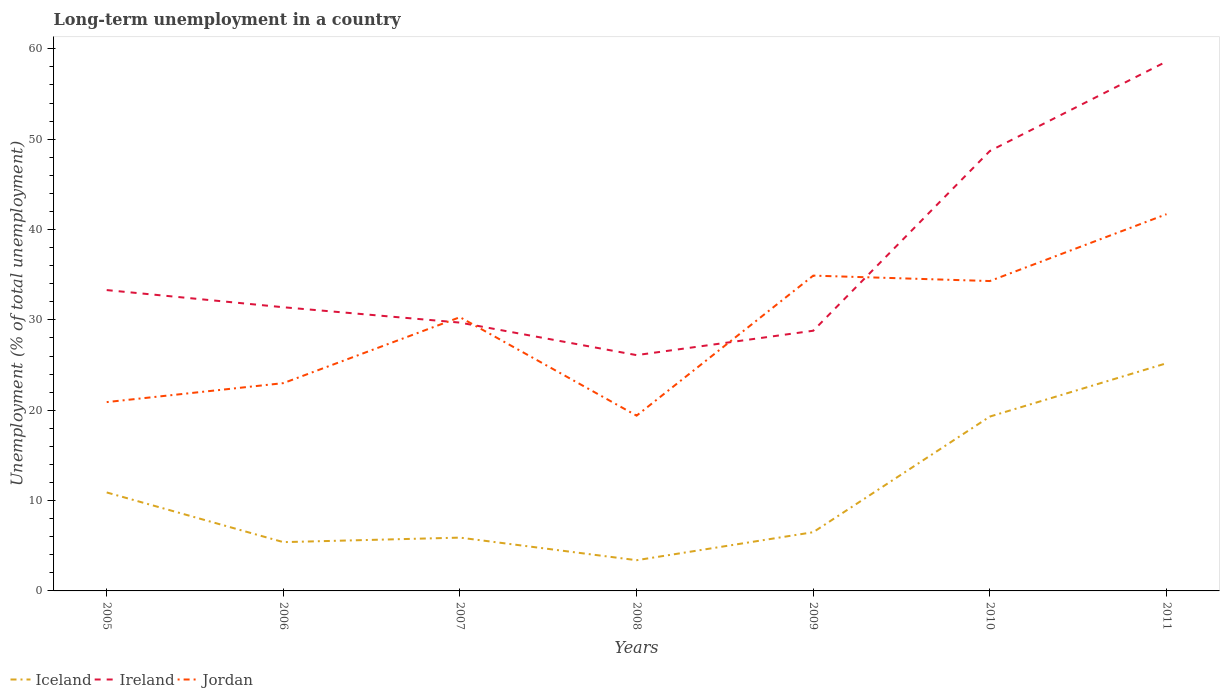Does the line corresponding to Ireland intersect with the line corresponding to Iceland?
Give a very brief answer. No. Across all years, what is the maximum percentage of long-term unemployed population in Jordan?
Provide a succinct answer. 19.4. What is the total percentage of long-term unemployed population in Jordan in the graph?
Provide a succinct answer. -7.3. What is the difference between the highest and the second highest percentage of long-term unemployed population in Iceland?
Make the answer very short. 21.8. What is the difference between the highest and the lowest percentage of long-term unemployed population in Ireland?
Ensure brevity in your answer.  2. Is the percentage of long-term unemployed population in Iceland strictly greater than the percentage of long-term unemployed population in Ireland over the years?
Your answer should be very brief. Yes. What is the difference between two consecutive major ticks on the Y-axis?
Your answer should be compact. 10. Does the graph contain any zero values?
Provide a short and direct response. No. Does the graph contain grids?
Your answer should be compact. No. Where does the legend appear in the graph?
Provide a short and direct response. Bottom left. How are the legend labels stacked?
Your response must be concise. Horizontal. What is the title of the graph?
Offer a very short reply. Long-term unemployment in a country. Does "North America" appear as one of the legend labels in the graph?
Provide a succinct answer. No. What is the label or title of the X-axis?
Offer a terse response. Years. What is the label or title of the Y-axis?
Keep it short and to the point. Unemployment (% of total unemployment). What is the Unemployment (% of total unemployment) in Iceland in 2005?
Make the answer very short. 10.9. What is the Unemployment (% of total unemployment) of Ireland in 2005?
Offer a very short reply. 33.3. What is the Unemployment (% of total unemployment) in Jordan in 2005?
Offer a very short reply. 20.9. What is the Unemployment (% of total unemployment) in Iceland in 2006?
Make the answer very short. 5.4. What is the Unemployment (% of total unemployment) of Ireland in 2006?
Give a very brief answer. 31.4. What is the Unemployment (% of total unemployment) of Iceland in 2007?
Give a very brief answer. 5.9. What is the Unemployment (% of total unemployment) of Ireland in 2007?
Provide a short and direct response. 29.7. What is the Unemployment (% of total unemployment) of Jordan in 2007?
Offer a very short reply. 30.3. What is the Unemployment (% of total unemployment) in Iceland in 2008?
Provide a short and direct response. 3.4. What is the Unemployment (% of total unemployment) of Ireland in 2008?
Keep it short and to the point. 26.1. What is the Unemployment (% of total unemployment) in Jordan in 2008?
Your answer should be very brief. 19.4. What is the Unemployment (% of total unemployment) in Iceland in 2009?
Your answer should be compact. 6.5. What is the Unemployment (% of total unemployment) of Ireland in 2009?
Your answer should be compact. 28.8. What is the Unemployment (% of total unemployment) in Jordan in 2009?
Provide a short and direct response. 34.9. What is the Unemployment (% of total unemployment) in Iceland in 2010?
Give a very brief answer. 19.3. What is the Unemployment (% of total unemployment) of Ireland in 2010?
Make the answer very short. 48.7. What is the Unemployment (% of total unemployment) of Jordan in 2010?
Provide a short and direct response. 34.3. What is the Unemployment (% of total unemployment) of Iceland in 2011?
Provide a short and direct response. 25.2. What is the Unemployment (% of total unemployment) of Ireland in 2011?
Provide a short and direct response. 58.6. What is the Unemployment (% of total unemployment) in Jordan in 2011?
Provide a short and direct response. 41.7. Across all years, what is the maximum Unemployment (% of total unemployment) of Iceland?
Make the answer very short. 25.2. Across all years, what is the maximum Unemployment (% of total unemployment) of Ireland?
Offer a very short reply. 58.6. Across all years, what is the maximum Unemployment (% of total unemployment) of Jordan?
Offer a terse response. 41.7. Across all years, what is the minimum Unemployment (% of total unemployment) in Iceland?
Ensure brevity in your answer.  3.4. Across all years, what is the minimum Unemployment (% of total unemployment) in Ireland?
Provide a short and direct response. 26.1. Across all years, what is the minimum Unemployment (% of total unemployment) in Jordan?
Give a very brief answer. 19.4. What is the total Unemployment (% of total unemployment) in Iceland in the graph?
Make the answer very short. 76.6. What is the total Unemployment (% of total unemployment) of Ireland in the graph?
Give a very brief answer. 256.6. What is the total Unemployment (% of total unemployment) in Jordan in the graph?
Provide a short and direct response. 204.5. What is the difference between the Unemployment (% of total unemployment) of Iceland in 2005 and that in 2006?
Provide a succinct answer. 5.5. What is the difference between the Unemployment (% of total unemployment) in Ireland in 2005 and that in 2006?
Give a very brief answer. 1.9. What is the difference between the Unemployment (% of total unemployment) in Iceland in 2005 and that in 2008?
Give a very brief answer. 7.5. What is the difference between the Unemployment (% of total unemployment) of Ireland in 2005 and that in 2009?
Keep it short and to the point. 4.5. What is the difference between the Unemployment (% of total unemployment) of Jordan in 2005 and that in 2009?
Provide a short and direct response. -14. What is the difference between the Unemployment (% of total unemployment) of Ireland in 2005 and that in 2010?
Offer a terse response. -15.4. What is the difference between the Unemployment (% of total unemployment) of Iceland in 2005 and that in 2011?
Give a very brief answer. -14.3. What is the difference between the Unemployment (% of total unemployment) in Ireland in 2005 and that in 2011?
Offer a very short reply. -25.3. What is the difference between the Unemployment (% of total unemployment) in Jordan in 2005 and that in 2011?
Your answer should be compact. -20.8. What is the difference between the Unemployment (% of total unemployment) in Ireland in 2006 and that in 2007?
Your response must be concise. 1.7. What is the difference between the Unemployment (% of total unemployment) of Ireland in 2006 and that in 2008?
Ensure brevity in your answer.  5.3. What is the difference between the Unemployment (% of total unemployment) of Jordan in 2006 and that in 2008?
Your answer should be very brief. 3.6. What is the difference between the Unemployment (% of total unemployment) of Ireland in 2006 and that in 2009?
Keep it short and to the point. 2.6. What is the difference between the Unemployment (% of total unemployment) in Jordan in 2006 and that in 2009?
Provide a short and direct response. -11.9. What is the difference between the Unemployment (% of total unemployment) of Ireland in 2006 and that in 2010?
Your answer should be very brief. -17.3. What is the difference between the Unemployment (% of total unemployment) in Jordan in 2006 and that in 2010?
Provide a succinct answer. -11.3. What is the difference between the Unemployment (% of total unemployment) of Iceland in 2006 and that in 2011?
Give a very brief answer. -19.8. What is the difference between the Unemployment (% of total unemployment) in Ireland in 2006 and that in 2011?
Give a very brief answer. -27.2. What is the difference between the Unemployment (% of total unemployment) of Jordan in 2006 and that in 2011?
Offer a terse response. -18.7. What is the difference between the Unemployment (% of total unemployment) in Iceland in 2007 and that in 2008?
Provide a short and direct response. 2.5. What is the difference between the Unemployment (% of total unemployment) in Iceland in 2007 and that in 2009?
Make the answer very short. -0.6. What is the difference between the Unemployment (% of total unemployment) of Ireland in 2007 and that in 2009?
Make the answer very short. 0.9. What is the difference between the Unemployment (% of total unemployment) of Ireland in 2007 and that in 2010?
Provide a short and direct response. -19. What is the difference between the Unemployment (% of total unemployment) of Jordan in 2007 and that in 2010?
Make the answer very short. -4. What is the difference between the Unemployment (% of total unemployment) in Iceland in 2007 and that in 2011?
Your answer should be compact. -19.3. What is the difference between the Unemployment (% of total unemployment) in Ireland in 2007 and that in 2011?
Your response must be concise. -28.9. What is the difference between the Unemployment (% of total unemployment) of Iceland in 2008 and that in 2009?
Keep it short and to the point. -3.1. What is the difference between the Unemployment (% of total unemployment) of Jordan in 2008 and that in 2009?
Give a very brief answer. -15.5. What is the difference between the Unemployment (% of total unemployment) of Iceland in 2008 and that in 2010?
Offer a very short reply. -15.9. What is the difference between the Unemployment (% of total unemployment) of Ireland in 2008 and that in 2010?
Keep it short and to the point. -22.6. What is the difference between the Unemployment (% of total unemployment) of Jordan in 2008 and that in 2010?
Keep it short and to the point. -14.9. What is the difference between the Unemployment (% of total unemployment) in Iceland in 2008 and that in 2011?
Your answer should be compact. -21.8. What is the difference between the Unemployment (% of total unemployment) of Ireland in 2008 and that in 2011?
Provide a short and direct response. -32.5. What is the difference between the Unemployment (% of total unemployment) in Jordan in 2008 and that in 2011?
Your answer should be compact. -22.3. What is the difference between the Unemployment (% of total unemployment) of Iceland in 2009 and that in 2010?
Give a very brief answer. -12.8. What is the difference between the Unemployment (% of total unemployment) of Ireland in 2009 and that in 2010?
Ensure brevity in your answer.  -19.9. What is the difference between the Unemployment (% of total unemployment) of Jordan in 2009 and that in 2010?
Provide a succinct answer. 0.6. What is the difference between the Unemployment (% of total unemployment) of Iceland in 2009 and that in 2011?
Ensure brevity in your answer.  -18.7. What is the difference between the Unemployment (% of total unemployment) in Ireland in 2009 and that in 2011?
Ensure brevity in your answer.  -29.8. What is the difference between the Unemployment (% of total unemployment) in Iceland in 2010 and that in 2011?
Your response must be concise. -5.9. What is the difference between the Unemployment (% of total unemployment) of Ireland in 2010 and that in 2011?
Provide a succinct answer. -9.9. What is the difference between the Unemployment (% of total unemployment) in Jordan in 2010 and that in 2011?
Offer a terse response. -7.4. What is the difference between the Unemployment (% of total unemployment) of Iceland in 2005 and the Unemployment (% of total unemployment) of Ireland in 2006?
Provide a short and direct response. -20.5. What is the difference between the Unemployment (% of total unemployment) of Iceland in 2005 and the Unemployment (% of total unemployment) of Jordan in 2006?
Keep it short and to the point. -12.1. What is the difference between the Unemployment (% of total unemployment) in Ireland in 2005 and the Unemployment (% of total unemployment) in Jordan in 2006?
Provide a succinct answer. 10.3. What is the difference between the Unemployment (% of total unemployment) in Iceland in 2005 and the Unemployment (% of total unemployment) in Ireland in 2007?
Make the answer very short. -18.8. What is the difference between the Unemployment (% of total unemployment) in Iceland in 2005 and the Unemployment (% of total unemployment) in Jordan in 2007?
Make the answer very short. -19.4. What is the difference between the Unemployment (% of total unemployment) of Ireland in 2005 and the Unemployment (% of total unemployment) of Jordan in 2007?
Your answer should be compact. 3. What is the difference between the Unemployment (% of total unemployment) of Iceland in 2005 and the Unemployment (% of total unemployment) of Ireland in 2008?
Your answer should be compact. -15.2. What is the difference between the Unemployment (% of total unemployment) in Iceland in 2005 and the Unemployment (% of total unemployment) in Jordan in 2008?
Provide a succinct answer. -8.5. What is the difference between the Unemployment (% of total unemployment) in Ireland in 2005 and the Unemployment (% of total unemployment) in Jordan in 2008?
Ensure brevity in your answer.  13.9. What is the difference between the Unemployment (% of total unemployment) of Iceland in 2005 and the Unemployment (% of total unemployment) of Ireland in 2009?
Provide a succinct answer. -17.9. What is the difference between the Unemployment (% of total unemployment) of Ireland in 2005 and the Unemployment (% of total unemployment) of Jordan in 2009?
Your answer should be very brief. -1.6. What is the difference between the Unemployment (% of total unemployment) in Iceland in 2005 and the Unemployment (% of total unemployment) in Ireland in 2010?
Provide a succinct answer. -37.8. What is the difference between the Unemployment (% of total unemployment) in Iceland in 2005 and the Unemployment (% of total unemployment) in Jordan in 2010?
Provide a succinct answer. -23.4. What is the difference between the Unemployment (% of total unemployment) of Iceland in 2005 and the Unemployment (% of total unemployment) of Ireland in 2011?
Make the answer very short. -47.7. What is the difference between the Unemployment (% of total unemployment) of Iceland in 2005 and the Unemployment (% of total unemployment) of Jordan in 2011?
Keep it short and to the point. -30.8. What is the difference between the Unemployment (% of total unemployment) of Iceland in 2006 and the Unemployment (% of total unemployment) of Ireland in 2007?
Provide a succinct answer. -24.3. What is the difference between the Unemployment (% of total unemployment) of Iceland in 2006 and the Unemployment (% of total unemployment) of Jordan in 2007?
Your response must be concise. -24.9. What is the difference between the Unemployment (% of total unemployment) in Iceland in 2006 and the Unemployment (% of total unemployment) in Ireland in 2008?
Make the answer very short. -20.7. What is the difference between the Unemployment (% of total unemployment) of Iceland in 2006 and the Unemployment (% of total unemployment) of Jordan in 2008?
Make the answer very short. -14. What is the difference between the Unemployment (% of total unemployment) in Ireland in 2006 and the Unemployment (% of total unemployment) in Jordan in 2008?
Your answer should be very brief. 12. What is the difference between the Unemployment (% of total unemployment) in Iceland in 2006 and the Unemployment (% of total unemployment) in Ireland in 2009?
Offer a very short reply. -23.4. What is the difference between the Unemployment (% of total unemployment) of Iceland in 2006 and the Unemployment (% of total unemployment) of Jordan in 2009?
Give a very brief answer. -29.5. What is the difference between the Unemployment (% of total unemployment) in Ireland in 2006 and the Unemployment (% of total unemployment) in Jordan in 2009?
Offer a terse response. -3.5. What is the difference between the Unemployment (% of total unemployment) in Iceland in 2006 and the Unemployment (% of total unemployment) in Ireland in 2010?
Provide a short and direct response. -43.3. What is the difference between the Unemployment (% of total unemployment) of Iceland in 2006 and the Unemployment (% of total unemployment) of Jordan in 2010?
Keep it short and to the point. -28.9. What is the difference between the Unemployment (% of total unemployment) of Iceland in 2006 and the Unemployment (% of total unemployment) of Ireland in 2011?
Your answer should be very brief. -53.2. What is the difference between the Unemployment (% of total unemployment) of Iceland in 2006 and the Unemployment (% of total unemployment) of Jordan in 2011?
Offer a very short reply. -36.3. What is the difference between the Unemployment (% of total unemployment) of Iceland in 2007 and the Unemployment (% of total unemployment) of Ireland in 2008?
Your answer should be compact. -20.2. What is the difference between the Unemployment (% of total unemployment) in Ireland in 2007 and the Unemployment (% of total unemployment) in Jordan in 2008?
Make the answer very short. 10.3. What is the difference between the Unemployment (% of total unemployment) of Iceland in 2007 and the Unemployment (% of total unemployment) of Ireland in 2009?
Provide a short and direct response. -22.9. What is the difference between the Unemployment (% of total unemployment) in Iceland in 2007 and the Unemployment (% of total unemployment) in Ireland in 2010?
Make the answer very short. -42.8. What is the difference between the Unemployment (% of total unemployment) of Iceland in 2007 and the Unemployment (% of total unemployment) of Jordan in 2010?
Give a very brief answer. -28.4. What is the difference between the Unemployment (% of total unemployment) of Iceland in 2007 and the Unemployment (% of total unemployment) of Ireland in 2011?
Keep it short and to the point. -52.7. What is the difference between the Unemployment (% of total unemployment) in Iceland in 2007 and the Unemployment (% of total unemployment) in Jordan in 2011?
Make the answer very short. -35.8. What is the difference between the Unemployment (% of total unemployment) of Ireland in 2007 and the Unemployment (% of total unemployment) of Jordan in 2011?
Provide a short and direct response. -12. What is the difference between the Unemployment (% of total unemployment) of Iceland in 2008 and the Unemployment (% of total unemployment) of Ireland in 2009?
Offer a very short reply. -25.4. What is the difference between the Unemployment (% of total unemployment) of Iceland in 2008 and the Unemployment (% of total unemployment) of Jordan in 2009?
Ensure brevity in your answer.  -31.5. What is the difference between the Unemployment (% of total unemployment) of Ireland in 2008 and the Unemployment (% of total unemployment) of Jordan in 2009?
Your answer should be compact. -8.8. What is the difference between the Unemployment (% of total unemployment) of Iceland in 2008 and the Unemployment (% of total unemployment) of Ireland in 2010?
Keep it short and to the point. -45.3. What is the difference between the Unemployment (% of total unemployment) in Iceland in 2008 and the Unemployment (% of total unemployment) in Jordan in 2010?
Provide a succinct answer. -30.9. What is the difference between the Unemployment (% of total unemployment) in Ireland in 2008 and the Unemployment (% of total unemployment) in Jordan in 2010?
Your answer should be compact. -8.2. What is the difference between the Unemployment (% of total unemployment) in Iceland in 2008 and the Unemployment (% of total unemployment) in Ireland in 2011?
Your response must be concise. -55.2. What is the difference between the Unemployment (% of total unemployment) of Iceland in 2008 and the Unemployment (% of total unemployment) of Jordan in 2011?
Provide a succinct answer. -38.3. What is the difference between the Unemployment (% of total unemployment) in Ireland in 2008 and the Unemployment (% of total unemployment) in Jordan in 2011?
Offer a terse response. -15.6. What is the difference between the Unemployment (% of total unemployment) of Iceland in 2009 and the Unemployment (% of total unemployment) of Ireland in 2010?
Your answer should be compact. -42.2. What is the difference between the Unemployment (% of total unemployment) of Iceland in 2009 and the Unemployment (% of total unemployment) of Jordan in 2010?
Give a very brief answer. -27.8. What is the difference between the Unemployment (% of total unemployment) of Iceland in 2009 and the Unemployment (% of total unemployment) of Ireland in 2011?
Your answer should be very brief. -52.1. What is the difference between the Unemployment (% of total unemployment) of Iceland in 2009 and the Unemployment (% of total unemployment) of Jordan in 2011?
Ensure brevity in your answer.  -35.2. What is the difference between the Unemployment (% of total unemployment) in Ireland in 2009 and the Unemployment (% of total unemployment) in Jordan in 2011?
Keep it short and to the point. -12.9. What is the difference between the Unemployment (% of total unemployment) in Iceland in 2010 and the Unemployment (% of total unemployment) in Ireland in 2011?
Your answer should be very brief. -39.3. What is the difference between the Unemployment (% of total unemployment) in Iceland in 2010 and the Unemployment (% of total unemployment) in Jordan in 2011?
Your response must be concise. -22.4. What is the average Unemployment (% of total unemployment) in Iceland per year?
Keep it short and to the point. 10.94. What is the average Unemployment (% of total unemployment) in Ireland per year?
Give a very brief answer. 36.66. What is the average Unemployment (% of total unemployment) in Jordan per year?
Ensure brevity in your answer.  29.21. In the year 2005, what is the difference between the Unemployment (% of total unemployment) in Iceland and Unemployment (% of total unemployment) in Ireland?
Your response must be concise. -22.4. In the year 2005, what is the difference between the Unemployment (% of total unemployment) in Ireland and Unemployment (% of total unemployment) in Jordan?
Offer a terse response. 12.4. In the year 2006, what is the difference between the Unemployment (% of total unemployment) of Iceland and Unemployment (% of total unemployment) of Ireland?
Ensure brevity in your answer.  -26. In the year 2006, what is the difference between the Unemployment (% of total unemployment) of Iceland and Unemployment (% of total unemployment) of Jordan?
Provide a short and direct response. -17.6. In the year 2007, what is the difference between the Unemployment (% of total unemployment) of Iceland and Unemployment (% of total unemployment) of Ireland?
Make the answer very short. -23.8. In the year 2007, what is the difference between the Unemployment (% of total unemployment) in Iceland and Unemployment (% of total unemployment) in Jordan?
Ensure brevity in your answer.  -24.4. In the year 2007, what is the difference between the Unemployment (% of total unemployment) in Ireland and Unemployment (% of total unemployment) in Jordan?
Offer a terse response. -0.6. In the year 2008, what is the difference between the Unemployment (% of total unemployment) of Iceland and Unemployment (% of total unemployment) of Ireland?
Ensure brevity in your answer.  -22.7. In the year 2009, what is the difference between the Unemployment (% of total unemployment) of Iceland and Unemployment (% of total unemployment) of Ireland?
Your answer should be very brief. -22.3. In the year 2009, what is the difference between the Unemployment (% of total unemployment) in Iceland and Unemployment (% of total unemployment) in Jordan?
Your answer should be compact. -28.4. In the year 2010, what is the difference between the Unemployment (% of total unemployment) of Iceland and Unemployment (% of total unemployment) of Ireland?
Make the answer very short. -29.4. In the year 2010, what is the difference between the Unemployment (% of total unemployment) of Iceland and Unemployment (% of total unemployment) of Jordan?
Give a very brief answer. -15. In the year 2010, what is the difference between the Unemployment (% of total unemployment) in Ireland and Unemployment (% of total unemployment) in Jordan?
Offer a terse response. 14.4. In the year 2011, what is the difference between the Unemployment (% of total unemployment) in Iceland and Unemployment (% of total unemployment) in Ireland?
Provide a succinct answer. -33.4. In the year 2011, what is the difference between the Unemployment (% of total unemployment) in Iceland and Unemployment (% of total unemployment) in Jordan?
Your response must be concise. -16.5. In the year 2011, what is the difference between the Unemployment (% of total unemployment) in Ireland and Unemployment (% of total unemployment) in Jordan?
Give a very brief answer. 16.9. What is the ratio of the Unemployment (% of total unemployment) in Iceland in 2005 to that in 2006?
Your answer should be very brief. 2.02. What is the ratio of the Unemployment (% of total unemployment) in Ireland in 2005 to that in 2006?
Provide a succinct answer. 1.06. What is the ratio of the Unemployment (% of total unemployment) of Jordan in 2005 to that in 2006?
Your response must be concise. 0.91. What is the ratio of the Unemployment (% of total unemployment) of Iceland in 2005 to that in 2007?
Your answer should be very brief. 1.85. What is the ratio of the Unemployment (% of total unemployment) in Ireland in 2005 to that in 2007?
Offer a terse response. 1.12. What is the ratio of the Unemployment (% of total unemployment) in Jordan in 2005 to that in 2007?
Provide a succinct answer. 0.69. What is the ratio of the Unemployment (% of total unemployment) in Iceland in 2005 to that in 2008?
Make the answer very short. 3.21. What is the ratio of the Unemployment (% of total unemployment) of Ireland in 2005 to that in 2008?
Provide a succinct answer. 1.28. What is the ratio of the Unemployment (% of total unemployment) in Jordan in 2005 to that in 2008?
Offer a terse response. 1.08. What is the ratio of the Unemployment (% of total unemployment) of Iceland in 2005 to that in 2009?
Your answer should be very brief. 1.68. What is the ratio of the Unemployment (% of total unemployment) in Ireland in 2005 to that in 2009?
Your answer should be very brief. 1.16. What is the ratio of the Unemployment (% of total unemployment) of Jordan in 2005 to that in 2009?
Ensure brevity in your answer.  0.6. What is the ratio of the Unemployment (% of total unemployment) of Iceland in 2005 to that in 2010?
Your response must be concise. 0.56. What is the ratio of the Unemployment (% of total unemployment) of Ireland in 2005 to that in 2010?
Your answer should be compact. 0.68. What is the ratio of the Unemployment (% of total unemployment) in Jordan in 2005 to that in 2010?
Your response must be concise. 0.61. What is the ratio of the Unemployment (% of total unemployment) of Iceland in 2005 to that in 2011?
Your answer should be very brief. 0.43. What is the ratio of the Unemployment (% of total unemployment) in Ireland in 2005 to that in 2011?
Offer a terse response. 0.57. What is the ratio of the Unemployment (% of total unemployment) of Jordan in 2005 to that in 2011?
Ensure brevity in your answer.  0.5. What is the ratio of the Unemployment (% of total unemployment) of Iceland in 2006 to that in 2007?
Your answer should be very brief. 0.92. What is the ratio of the Unemployment (% of total unemployment) of Ireland in 2006 to that in 2007?
Provide a short and direct response. 1.06. What is the ratio of the Unemployment (% of total unemployment) in Jordan in 2006 to that in 2007?
Offer a very short reply. 0.76. What is the ratio of the Unemployment (% of total unemployment) of Iceland in 2006 to that in 2008?
Give a very brief answer. 1.59. What is the ratio of the Unemployment (% of total unemployment) of Ireland in 2006 to that in 2008?
Give a very brief answer. 1.2. What is the ratio of the Unemployment (% of total unemployment) in Jordan in 2006 to that in 2008?
Provide a succinct answer. 1.19. What is the ratio of the Unemployment (% of total unemployment) of Iceland in 2006 to that in 2009?
Your answer should be compact. 0.83. What is the ratio of the Unemployment (% of total unemployment) of Ireland in 2006 to that in 2009?
Provide a short and direct response. 1.09. What is the ratio of the Unemployment (% of total unemployment) of Jordan in 2006 to that in 2009?
Your response must be concise. 0.66. What is the ratio of the Unemployment (% of total unemployment) of Iceland in 2006 to that in 2010?
Make the answer very short. 0.28. What is the ratio of the Unemployment (% of total unemployment) in Ireland in 2006 to that in 2010?
Ensure brevity in your answer.  0.64. What is the ratio of the Unemployment (% of total unemployment) in Jordan in 2006 to that in 2010?
Provide a succinct answer. 0.67. What is the ratio of the Unemployment (% of total unemployment) of Iceland in 2006 to that in 2011?
Offer a very short reply. 0.21. What is the ratio of the Unemployment (% of total unemployment) of Ireland in 2006 to that in 2011?
Provide a succinct answer. 0.54. What is the ratio of the Unemployment (% of total unemployment) of Jordan in 2006 to that in 2011?
Offer a very short reply. 0.55. What is the ratio of the Unemployment (% of total unemployment) in Iceland in 2007 to that in 2008?
Ensure brevity in your answer.  1.74. What is the ratio of the Unemployment (% of total unemployment) in Ireland in 2007 to that in 2008?
Your answer should be very brief. 1.14. What is the ratio of the Unemployment (% of total unemployment) of Jordan in 2007 to that in 2008?
Your answer should be very brief. 1.56. What is the ratio of the Unemployment (% of total unemployment) in Iceland in 2007 to that in 2009?
Offer a very short reply. 0.91. What is the ratio of the Unemployment (% of total unemployment) of Ireland in 2007 to that in 2009?
Give a very brief answer. 1.03. What is the ratio of the Unemployment (% of total unemployment) in Jordan in 2007 to that in 2009?
Provide a succinct answer. 0.87. What is the ratio of the Unemployment (% of total unemployment) of Iceland in 2007 to that in 2010?
Ensure brevity in your answer.  0.31. What is the ratio of the Unemployment (% of total unemployment) in Ireland in 2007 to that in 2010?
Offer a very short reply. 0.61. What is the ratio of the Unemployment (% of total unemployment) of Jordan in 2007 to that in 2010?
Keep it short and to the point. 0.88. What is the ratio of the Unemployment (% of total unemployment) of Iceland in 2007 to that in 2011?
Ensure brevity in your answer.  0.23. What is the ratio of the Unemployment (% of total unemployment) in Ireland in 2007 to that in 2011?
Ensure brevity in your answer.  0.51. What is the ratio of the Unemployment (% of total unemployment) of Jordan in 2007 to that in 2011?
Give a very brief answer. 0.73. What is the ratio of the Unemployment (% of total unemployment) in Iceland in 2008 to that in 2009?
Provide a short and direct response. 0.52. What is the ratio of the Unemployment (% of total unemployment) in Ireland in 2008 to that in 2009?
Your response must be concise. 0.91. What is the ratio of the Unemployment (% of total unemployment) in Jordan in 2008 to that in 2009?
Your answer should be very brief. 0.56. What is the ratio of the Unemployment (% of total unemployment) in Iceland in 2008 to that in 2010?
Provide a succinct answer. 0.18. What is the ratio of the Unemployment (% of total unemployment) in Ireland in 2008 to that in 2010?
Give a very brief answer. 0.54. What is the ratio of the Unemployment (% of total unemployment) in Jordan in 2008 to that in 2010?
Keep it short and to the point. 0.57. What is the ratio of the Unemployment (% of total unemployment) in Iceland in 2008 to that in 2011?
Keep it short and to the point. 0.13. What is the ratio of the Unemployment (% of total unemployment) in Ireland in 2008 to that in 2011?
Keep it short and to the point. 0.45. What is the ratio of the Unemployment (% of total unemployment) of Jordan in 2008 to that in 2011?
Offer a terse response. 0.47. What is the ratio of the Unemployment (% of total unemployment) in Iceland in 2009 to that in 2010?
Ensure brevity in your answer.  0.34. What is the ratio of the Unemployment (% of total unemployment) in Ireland in 2009 to that in 2010?
Offer a very short reply. 0.59. What is the ratio of the Unemployment (% of total unemployment) of Jordan in 2009 to that in 2010?
Ensure brevity in your answer.  1.02. What is the ratio of the Unemployment (% of total unemployment) of Iceland in 2009 to that in 2011?
Provide a short and direct response. 0.26. What is the ratio of the Unemployment (% of total unemployment) of Ireland in 2009 to that in 2011?
Ensure brevity in your answer.  0.49. What is the ratio of the Unemployment (% of total unemployment) of Jordan in 2009 to that in 2011?
Provide a succinct answer. 0.84. What is the ratio of the Unemployment (% of total unemployment) in Iceland in 2010 to that in 2011?
Give a very brief answer. 0.77. What is the ratio of the Unemployment (% of total unemployment) in Ireland in 2010 to that in 2011?
Provide a short and direct response. 0.83. What is the ratio of the Unemployment (% of total unemployment) of Jordan in 2010 to that in 2011?
Your response must be concise. 0.82. What is the difference between the highest and the second highest Unemployment (% of total unemployment) in Iceland?
Your answer should be compact. 5.9. What is the difference between the highest and the second highest Unemployment (% of total unemployment) of Ireland?
Provide a short and direct response. 9.9. What is the difference between the highest and the second highest Unemployment (% of total unemployment) of Jordan?
Your answer should be very brief. 6.8. What is the difference between the highest and the lowest Unemployment (% of total unemployment) of Iceland?
Your response must be concise. 21.8. What is the difference between the highest and the lowest Unemployment (% of total unemployment) of Ireland?
Ensure brevity in your answer.  32.5. What is the difference between the highest and the lowest Unemployment (% of total unemployment) of Jordan?
Ensure brevity in your answer.  22.3. 